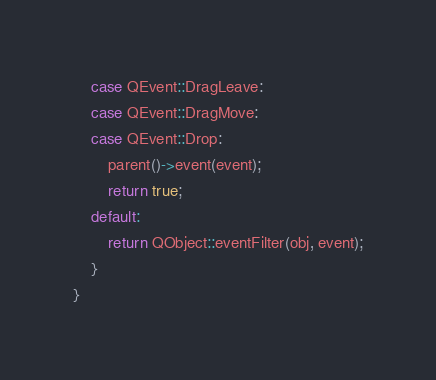Convert code to text. <code><loc_0><loc_0><loc_500><loc_500><_C++_>    case QEvent::DragLeave:
    case QEvent::DragMove:
    case QEvent::Drop:
        parent()->event(event);
        return true;
    default:
        return QObject::eventFilter(obj, event);
    }
}
</code> 